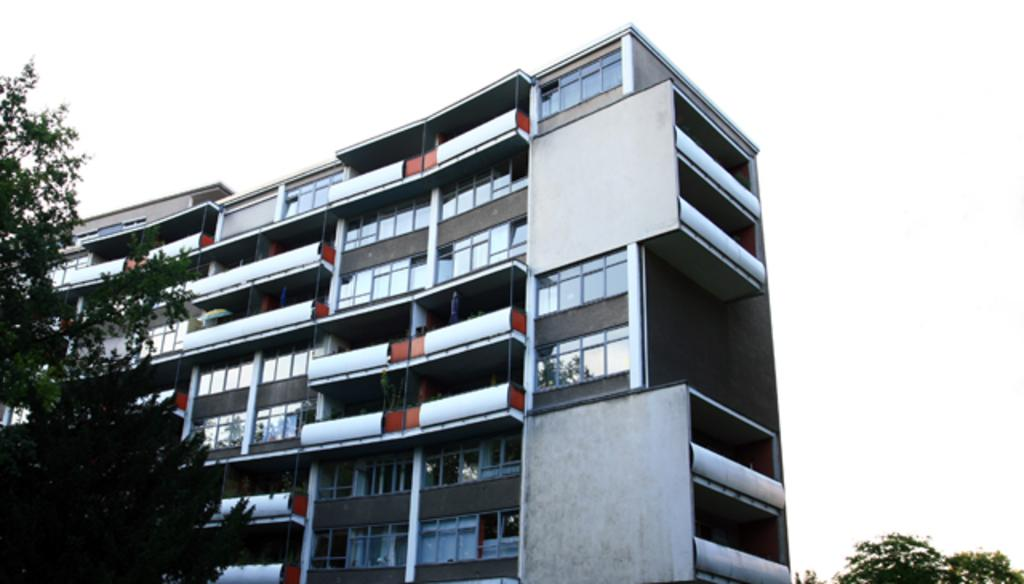What type of building is shown in the image? There is a building with glass windows in the image. What other elements can be seen in the image besides the building? Trees are visible in the image. What is visible in the background of the image? The sky is visible in the background of the image. Can you see any fangs or hooks in the image? No, there are no fangs or hooks present in the image. The image features a building with glass windows, trees, and the sky. 